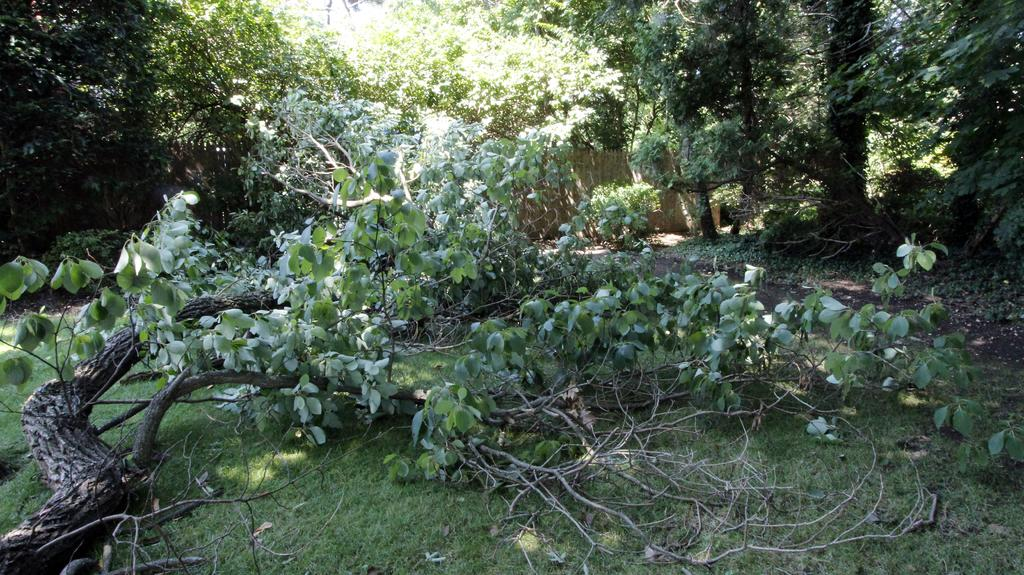What is the primary feature of the image? The primary feature of the image is the presence of many trees. Can you describe a specific part of a tree in the image? Yes, there is a tree branch visible in the image. Where is the tree branch located? The tree branch is on the grass. What type of fuel can be seen being used by the trees in the image? There is no fuel being used by the trees in the image, as trees do not require fuel to grow or function. 